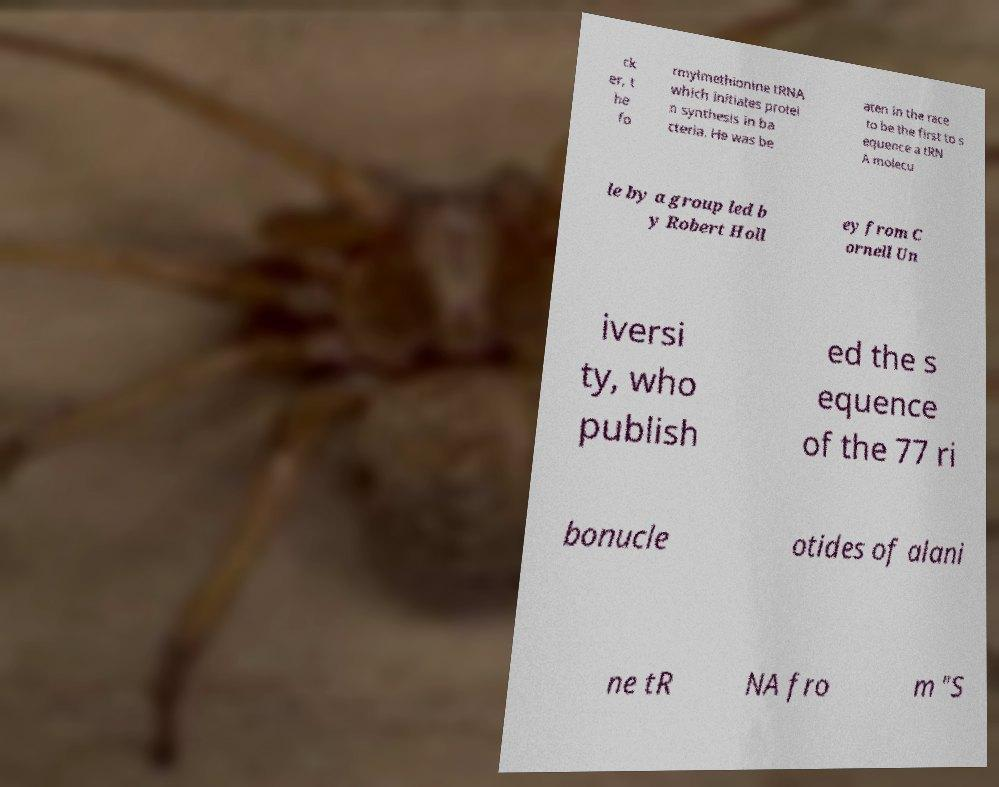What messages or text are displayed in this image? I need them in a readable, typed format. ck er, t he fo rmylmethionine tRNA which initiates protei n synthesis in ba cteria. He was be aten in the race to be the first to s equence a tRN A molecu le by a group led b y Robert Holl ey from C ornell Un iversi ty, who publish ed the s equence of the 77 ri bonucle otides of alani ne tR NA fro m "S 